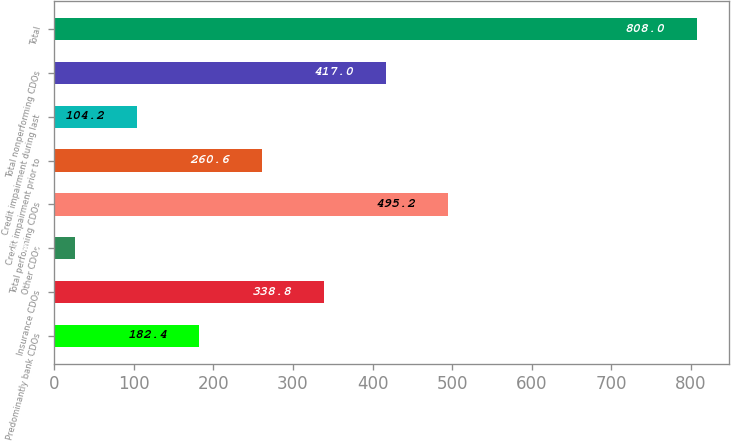Convert chart to OTSL. <chart><loc_0><loc_0><loc_500><loc_500><bar_chart><fcel>Predominantly bank CDOs<fcel>Insurance CDOs<fcel>Other CDOs<fcel>Total performing CDOs<fcel>Credit impairment prior to<fcel>Credit impairment during last<fcel>Total nonperforming CDOs<fcel>Total<nl><fcel>182.4<fcel>338.8<fcel>26<fcel>495.2<fcel>260.6<fcel>104.2<fcel>417<fcel>808<nl></chart> 